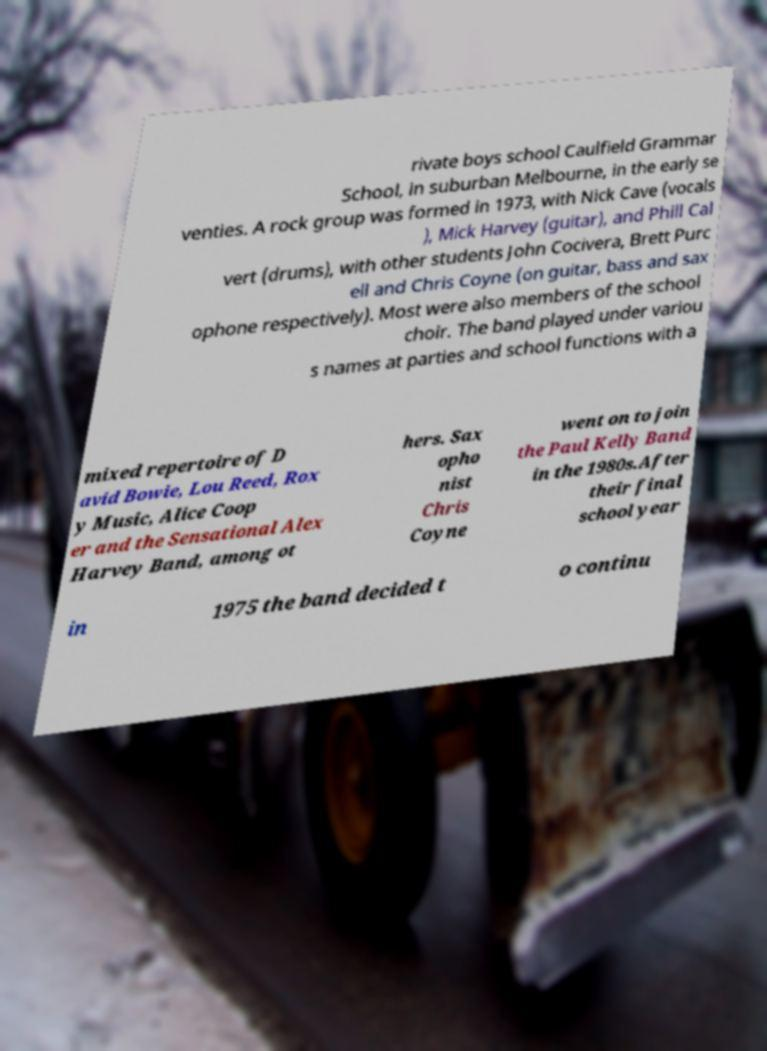Can you read and provide the text displayed in the image?This photo seems to have some interesting text. Can you extract and type it out for me? rivate boys school Caulfield Grammar School, in suburban Melbourne, in the early se venties. A rock group was formed in 1973, with Nick Cave (vocals ), Mick Harvey (guitar), and Phill Cal vert (drums), with other students John Cocivera, Brett Purc ell and Chris Coyne (on guitar, bass and sax ophone respectively). Most were also members of the school choir. The band played under variou s names at parties and school functions with a mixed repertoire of D avid Bowie, Lou Reed, Rox y Music, Alice Coop er and the Sensational Alex Harvey Band, among ot hers. Sax opho nist Chris Coyne went on to join the Paul Kelly Band in the 1980s.After their final school year in 1975 the band decided t o continu 